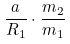<formula> <loc_0><loc_0><loc_500><loc_500>\frac { a } { R _ { 1 } } \cdot \frac { m _ { 2 } } { m _ { 1 } }</formula> 